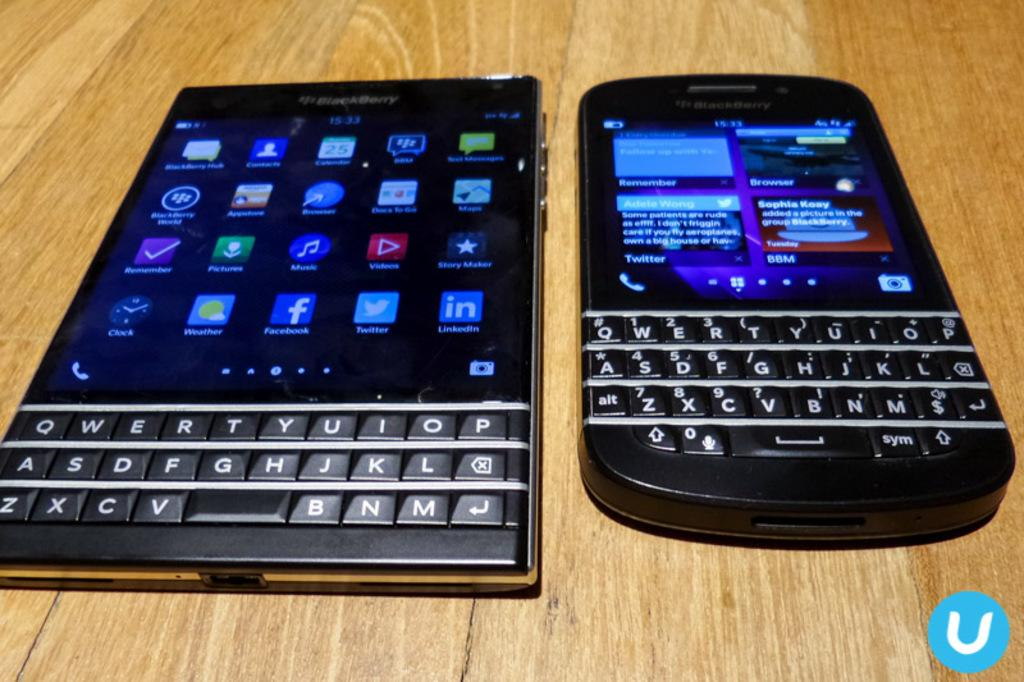<image>
Give a short and clear explanation of the subsequent image. a phone with the name of Sophia written on it 